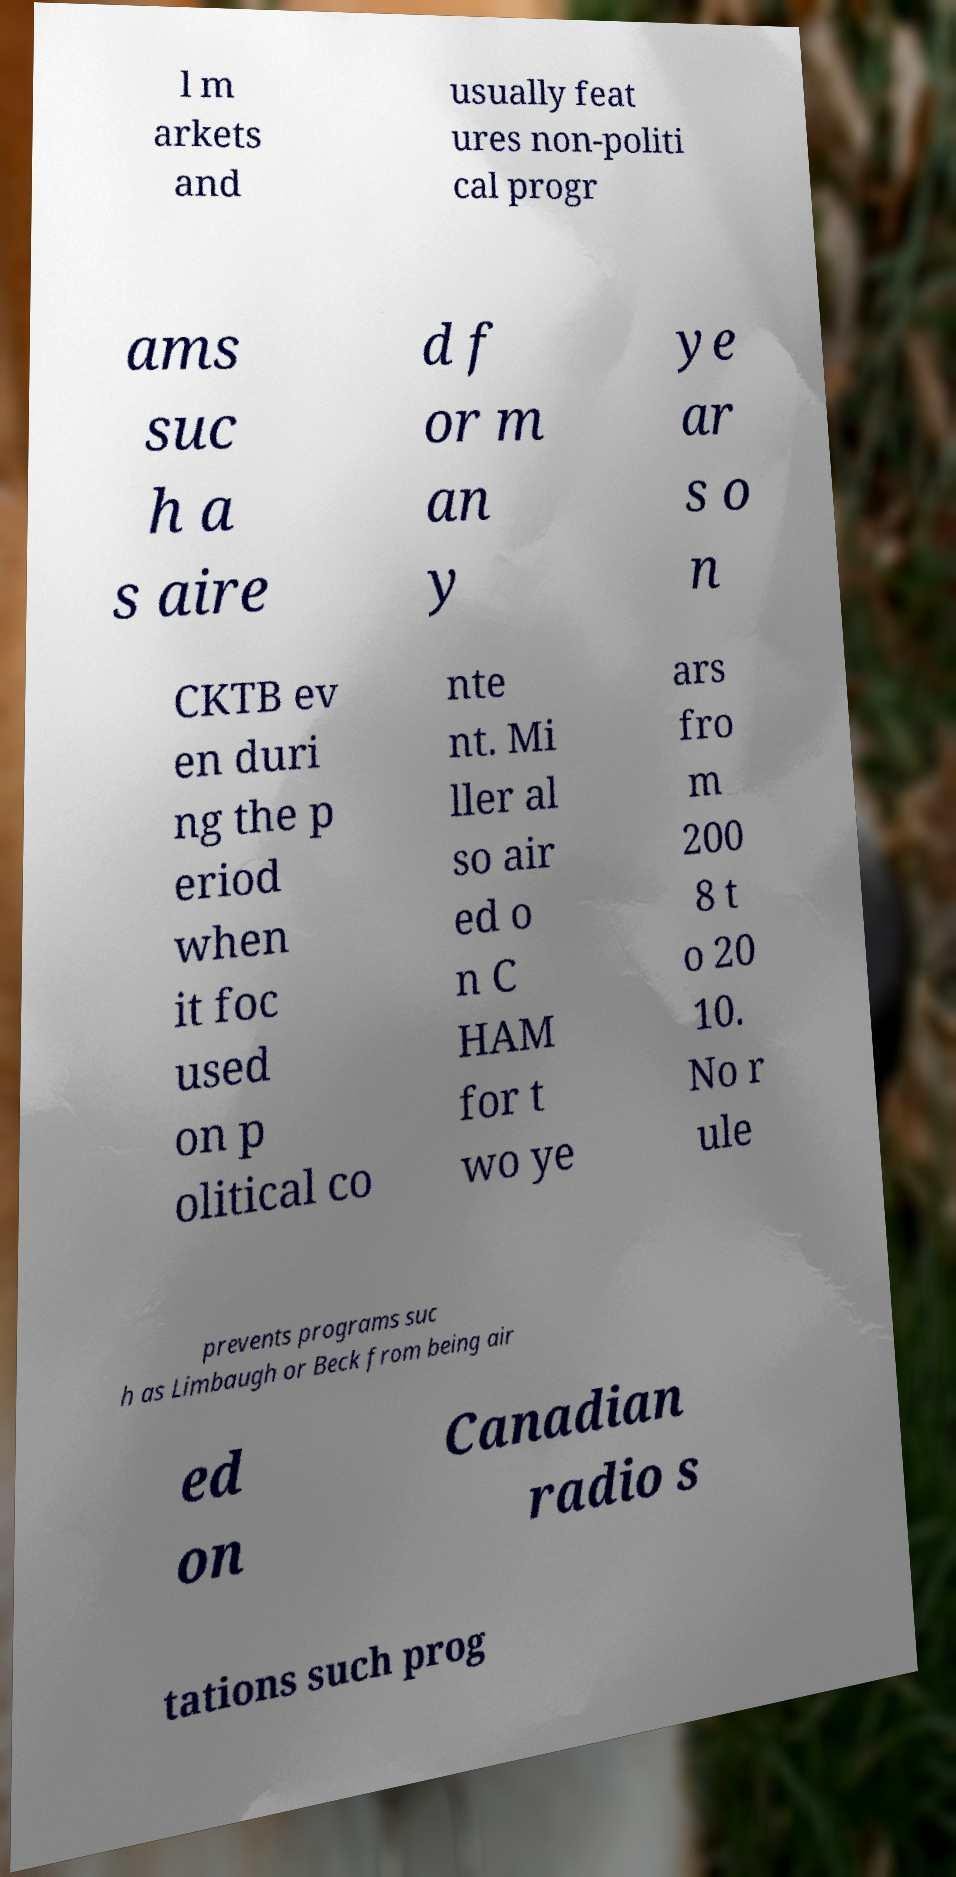I need the written content from this picture converted into text. Can you do that? l m arkets and usually feat ures non-politi cal progr ams suc h a s aire d f or m an y ye ar s o n CKTB ev en duri ng the p eriod when it foc used on p olitical co nte nt. Mi ller al so air ed o n C HAM for t wo ye ars fro m 200 8 t o 20 10. No r ule prevents programs suc h as Limbaugh or Beck from being air ed on Canadian radio s tations such prog 